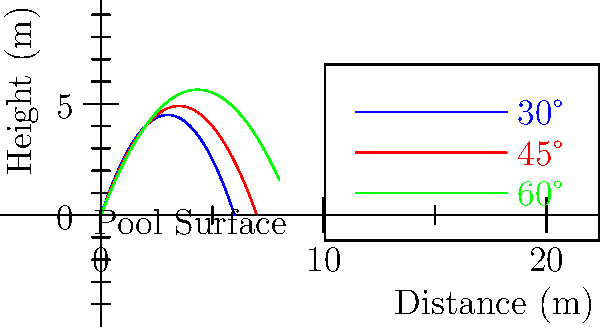Based on the dive trajectory diagram, which angle of entry appears to provide the optimal combination of distance and height for a competitive swimmer aiming to minimize water resistance upon entry? To determine the optimal angle for diving, we need to analyze the three trajectories shown in the diagram:

1. Blue curve (30°): This trajectory has a lower peak height but travels a moderate distance.
2. Red curve (45°): This trajectory achieves a balance between height and distance.
3. Green curve (60°): This trajectory reaches the greatest height but covers less horizontal distance.

For competitive swimming, the ideal dive should:
a) Provide sufficient height to clear the water's surface tension
b) Cover enough horizontal distance to gain momentum
c) Enter the water at an angle that minimizes resistance

Considering these factors:
- The 30° angle (blue) doesn't provide enough height, which could result in a "flat" entry and increased resistance.
- The 60° angle (green) provides too much height and not enough forward momentum, potentially slowing the swimmer down.
- The 45° angle (red) offers the best compromise between height and distance.

Additionally, a 45° entry angle is often considered ideal in fluid dynamics for minimizing water resistance upon entry. This angle allows the swimmer to pierce the water surface efficiently, creating a smaller hole and reducing the amount of water displaced.

Therefore, based on the diagram and competitive swimming principles, the 45° angle (red trajectory) appears to be the optimal choice for diving.
Answer: 45° 